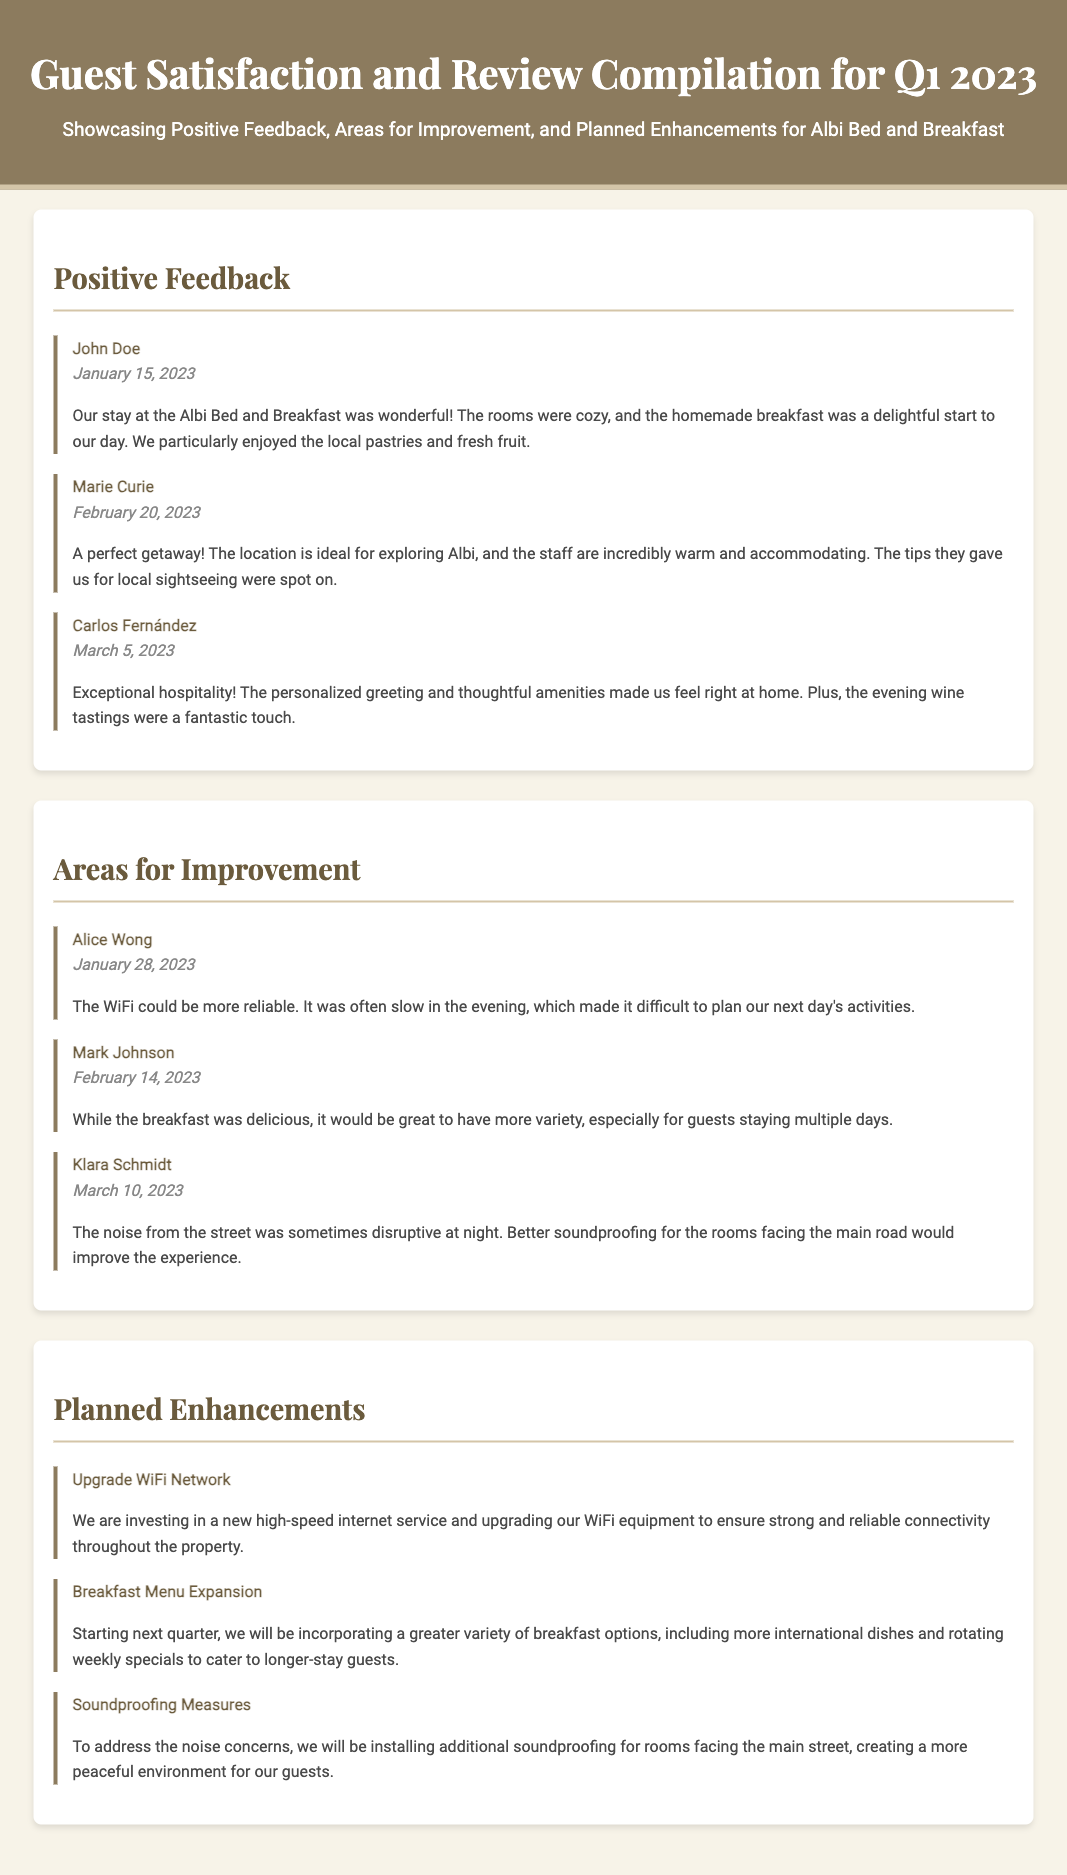What is the title of the document? The title of the document is presented in the header section, which conveys the purpose of the compilation.
Answer: Guest Satisfaction and Review Compilation for Q1 2023 Who gave positive feedback on January 15, 2023? This information can be retrieved from the section detailing positive feedback, listing feedback by reviewers along with their respective dates.
Answer: John Doe What area for improvement was mentioned by Alice Wong? The document contains a section where specific feedback for improvement is listed with the reviewer names and comments.
Answer: WiFi How many positive feedback entries are there? This is determined by counting the number of feedback-item entries under the Positive Feedback section.
Answer: Three What is one planned enhancement related to breakfast? This inquiry is answered by referring to the section that outlines future improvements, listing specific initiatives along with their content.
Answer: Breakfast Menu Expansion When was the feedback from Mark Johnson given? The date of Mark Johnson's feedback can be found in the areas for improvement section, next to his name.
Answer: February 14, 2023 What initiative is planned to address noise concerns? The planned enhancements section describes various improvements including specific initiatives aimed at addressing guest feedback.
Answer: Soundproofing Measures Who mentioned their enjoyment of local pastries? This detail can be extracted from the positive feedback section, where reviewers express their experience and highlights during their stay.
Answer: John Doe What will be included in the breakfast menu expansion? The document specifies that the breakfast menu will feature a greater variety of options, including certain types of dishes and specials.
Answer: More international dishes 